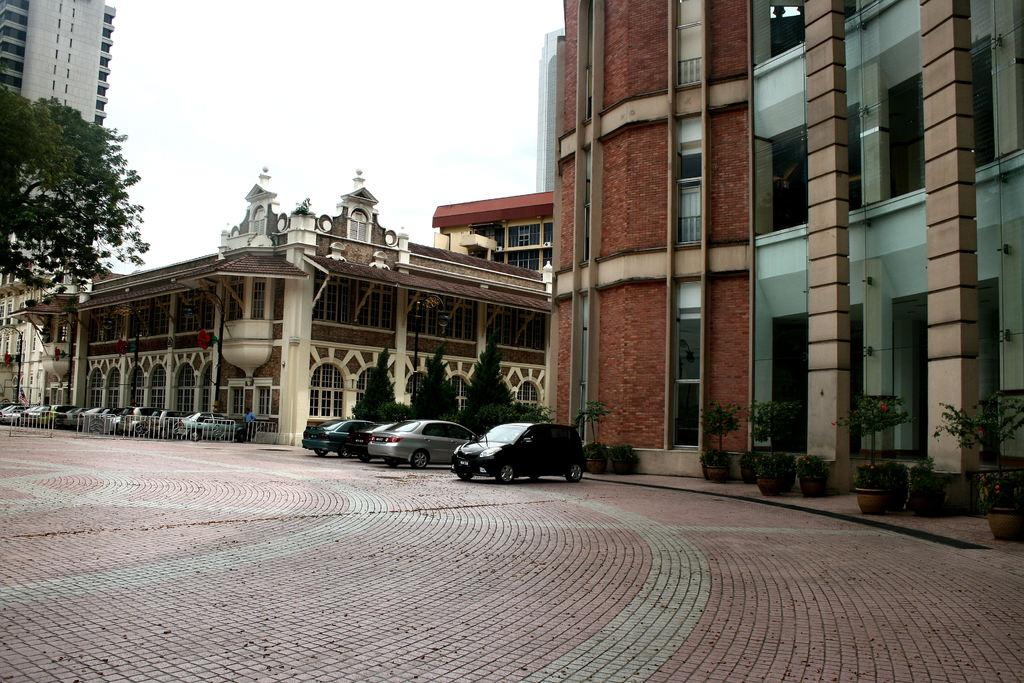How many cars can be seen in the image? There are three cars in the image. Where are the cars located in relation to the fencing? The cars are parked near to the fencing. What type of building can be seen in the top left corner of the image? There is a skyscraper in the top left corner of the image. What is visible at the top of the image? The sky is visible at the top of the image. What can be observed in the sky? Clouds are present in the sky. Can you see the roots of the trees growing through the pavement in the image? There are no trees or roots visible in the image. What type of waves can be seen crashing against the shore in the image? There is no shore or waves present in the image. 